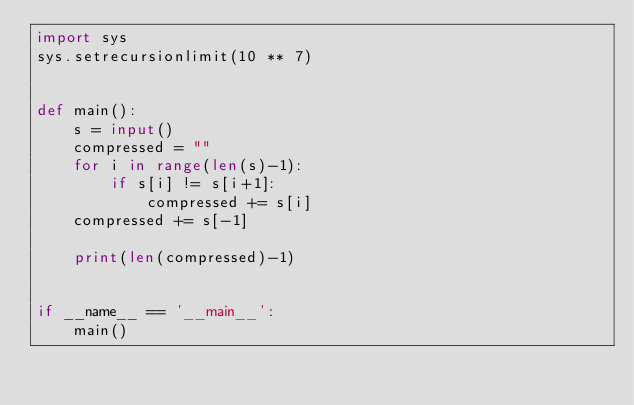Convert code to text. <code><loc_0><loc_0><loc_500><loc_500><_Python_>import sys
sys.setrecursionlimit(10 ** 7)


def main():
    s = input()
    compressed = ""
    for i in range(len(s)-1):
        if s[i] != s[i+1]:
            compressed += s[i]
    compressed += s[-1]

    print(len(compressed)-1)


if __name__ == '__main__':
    main()
</code> 